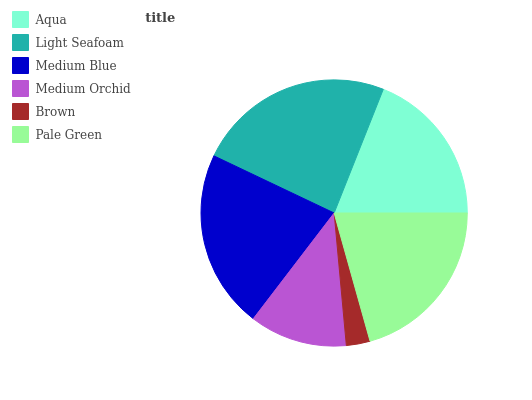Is Brown the minimum?
Answer yes or no. Yes. Is Light Seafoam the maximum?
Answer yes or no. Yes. Is Medium Blue the minimum?
Answer yes or no. No. Is Medium Blue the maximum?
Answer yes or no. No. Is Light Seafoam greater than Medium Blue?
Answer yes or no. Yes. Is Medium Blue less than Light Seafoam?
Answer yes or no. Yes. Is Medium Blue greater than Light Seafoam?
Answer yes or no. No. Is Light Seafoam less than Medium Blue?
Answer yes or no. No. Is Pale Green the high median?
Answer yes or no. Yes. Is Aqua the low median?
Answer yes or no. Yes. Is Light Seafoam the high median?
Answer yes or no. No. Is Brown the low median?
Answer yes or no. No. 